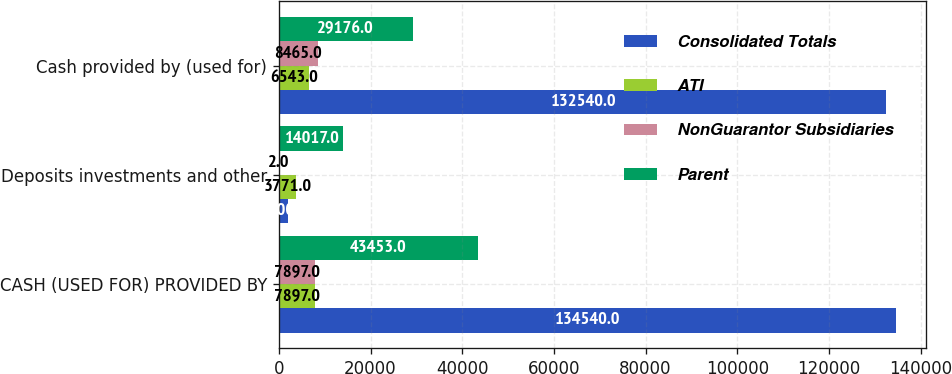Convert chart to OTSL. <chart><loc_0><loc_0><loc_500><loc_500><stacked_bar_chart><ecel><fcel>CASH (USED FOR) PROVIDED BY<fcel>Deposits investments and other<fcel>Cash provided by (used for)<nl><fcel>Consolidated Totals<fcel>134540<fcel>2000<fcel>132540<nl><fcel>ATI<fcel>7897<fcel>3771<fcel>6543<nl><fcel>NonGuarantor Subsidiaries<fcel>7897<fcel>2<fcel>8465<nl><fcel>Parent<fcel>43453<fcel>14017<fcel>29176<nl></chart> 